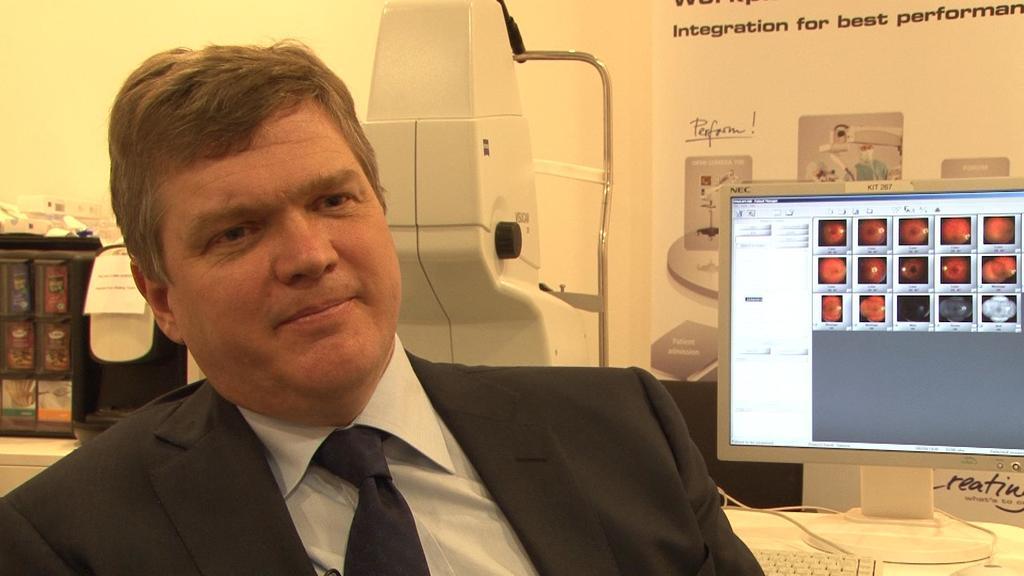Please provide a concise description of this image. In this image I can see the person wearing the blazer, white color shirt and also the tie. To the right I can see the system and keyboard on the table. In the back there is a paper attached to the wall. To the left I can see the black color object. I can also see the white color machine to the side. 